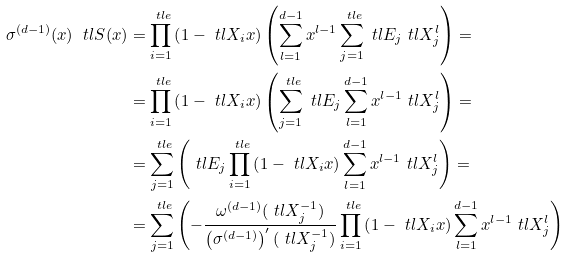<formula> <loc_0><loc_0><loc_500><loc_500>\sigma ^ { ( d - 1 ) } ( x ) \ t l { S } ( x ) & = \prod _ { i = 1 } ^ { \ t l { e } } \left ( 1 - \ t l { X } _ { i } x \right ) \left ( \sum _ { l = 1 } ^ { d - 1 } x ^ { l - 1 } \sum _ { j = 1 } ^ { \ t l { e } } \ t l { E } _ { j } \ t l { X } _ { j } ^ { l } \right ) = \\ & = \prod _ { i = 1 } ^ { \ t l { e } } \left ( 1 - \ t l { X } _ { i } x \right ) \left ( \sum _ { j = 1 } ^ { \ t l { e } } \ t l { E } _ { j } \sum _ { l = 1 } ^ { d - 1 } x ^ { l - 1 } \ t l { X } _ { j } ^ { l } \right ) = \\ & = \sum _ { j = 1 } ^ { \ t l { e } } \left ( \ t l { E } _ { j } \prod _ { i = 1 } ^ { \ t l { e } } \left ( 1 - \ t l { X } _ { i } x \right ) \sum _ { l = 1 } ^ { d - 1 } x ^ { l - 1 } \ t l { X } _ { j } ^ { l } \right ) = \\ & = \sum _ { j = 1 } ^ { \ t l { e } } \left ( - \frac { \omega ^ { ( d - 1 ) } ( \ t l { X } _ { j } ^ { - 1 } ) } { \left ( \sigma ^ { ( d - 1 ) } \right ) ^ { \prime } ( \ t l { X } _ { j } ^ { - 1 } ) } \prod _ { i = 1 } ^ { \ t l { e } } \left ( 1 - \ t l { X } _ { i } x \right ) \sum _ { l = 1 } ^ { d - 1 } x ^ { l - 1 } \ t l { X } _ { j } ^ { l } \right ) \\</formula> 